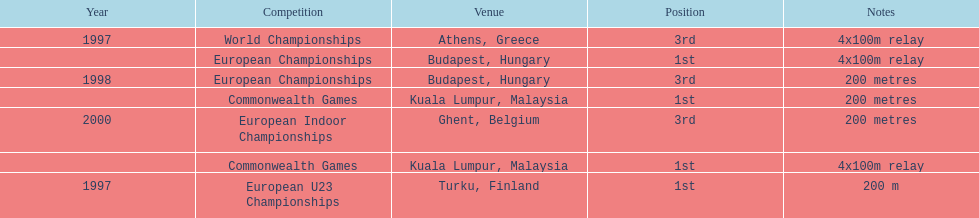Between 1997 and 2000, in which year did julian golding, a sprinter from the uk and england, win both the 4x100m relay and the 200m race? 1998. 